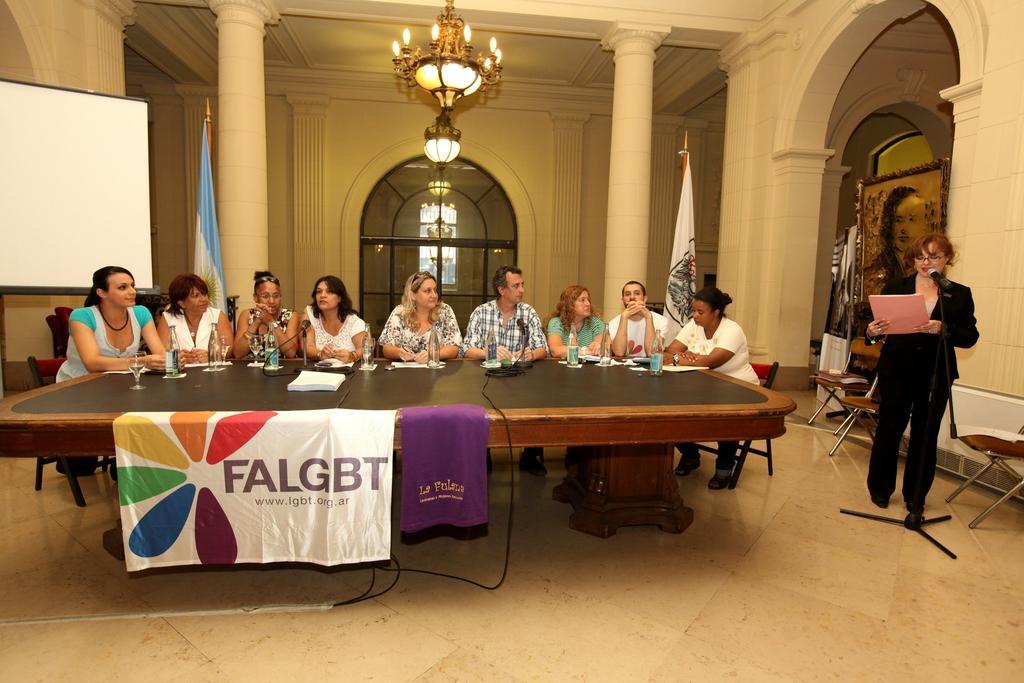Could you give a brief overview of what you see in this image? I can see a group of people among them, a woman standing on the floor and other people are sitting on the chair in front of a table. On the table we have few bottles and other objects on it. I can see there is a chandelier, white color board and other objects on the floor. 